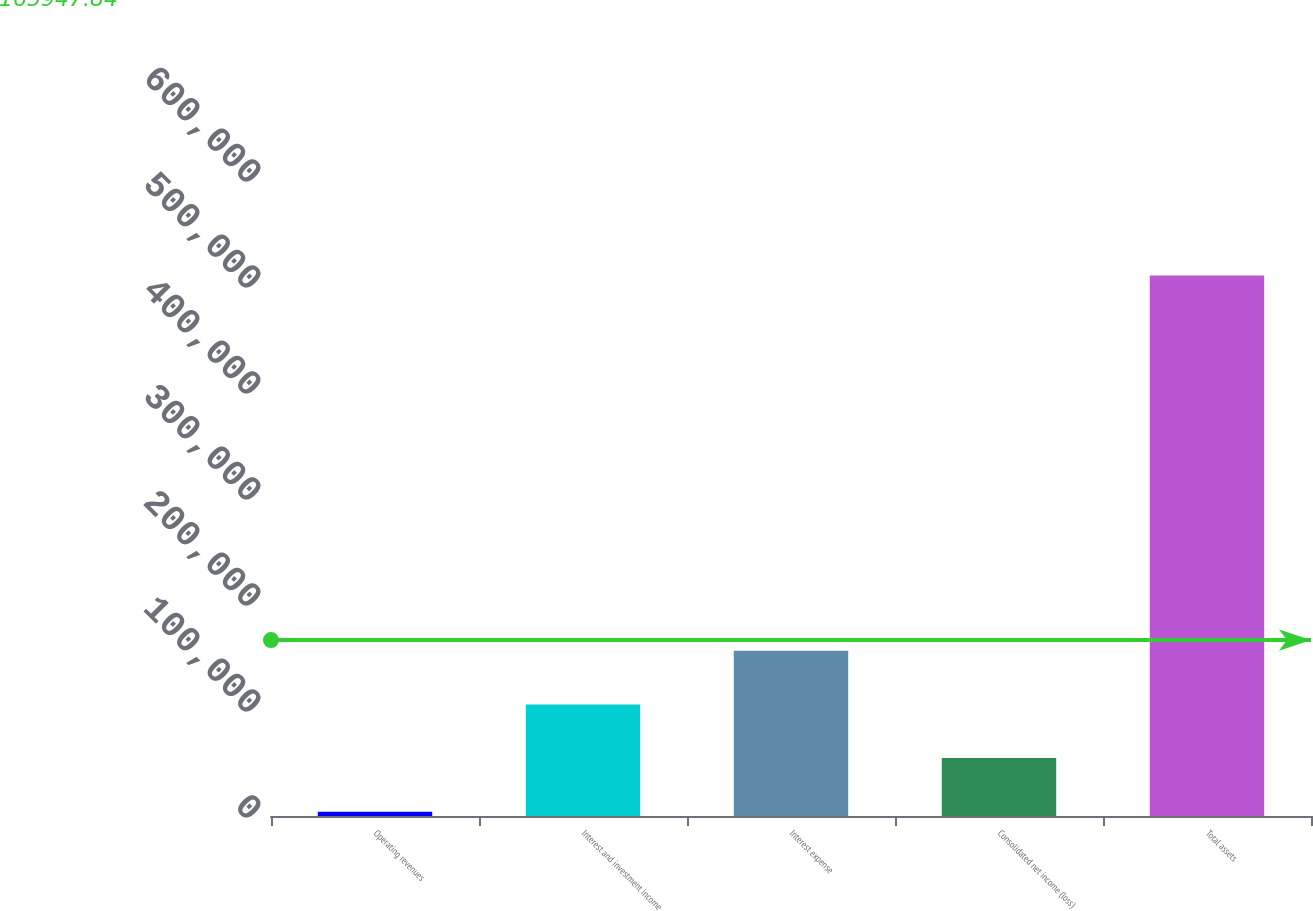Convert chart to OTSL. <chart><loc_0><loc_0><loc_500><loc_500><bar_chart><fcel>Operating revenues<fcel>Interest and investment income<fcel>Interest expense<fcel>Consolidated net income (loss)<fcel>Total assets<nl><fcel>4048<fcel>105235<fcel>155829<fcel>54641.7<fcel>509985<nl></chart> 